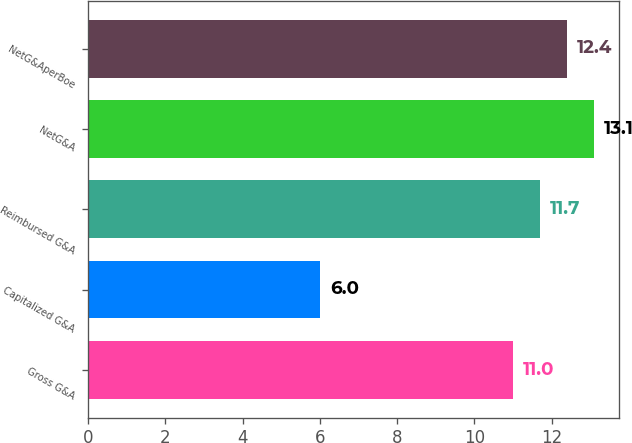<chart> <loc_0><loc_0><loc_500><loc_500><bar_chart><fcel>Gross G&A<fcel>Capitalized G&A<fcel>Reimbursed G&A<fcel>NetG&A<fcel>NetG&AperBoe<nl><fcel>11<fcel>6<fcel>11.7<fcel>13.1<fcel>12.4<nl></chart> 